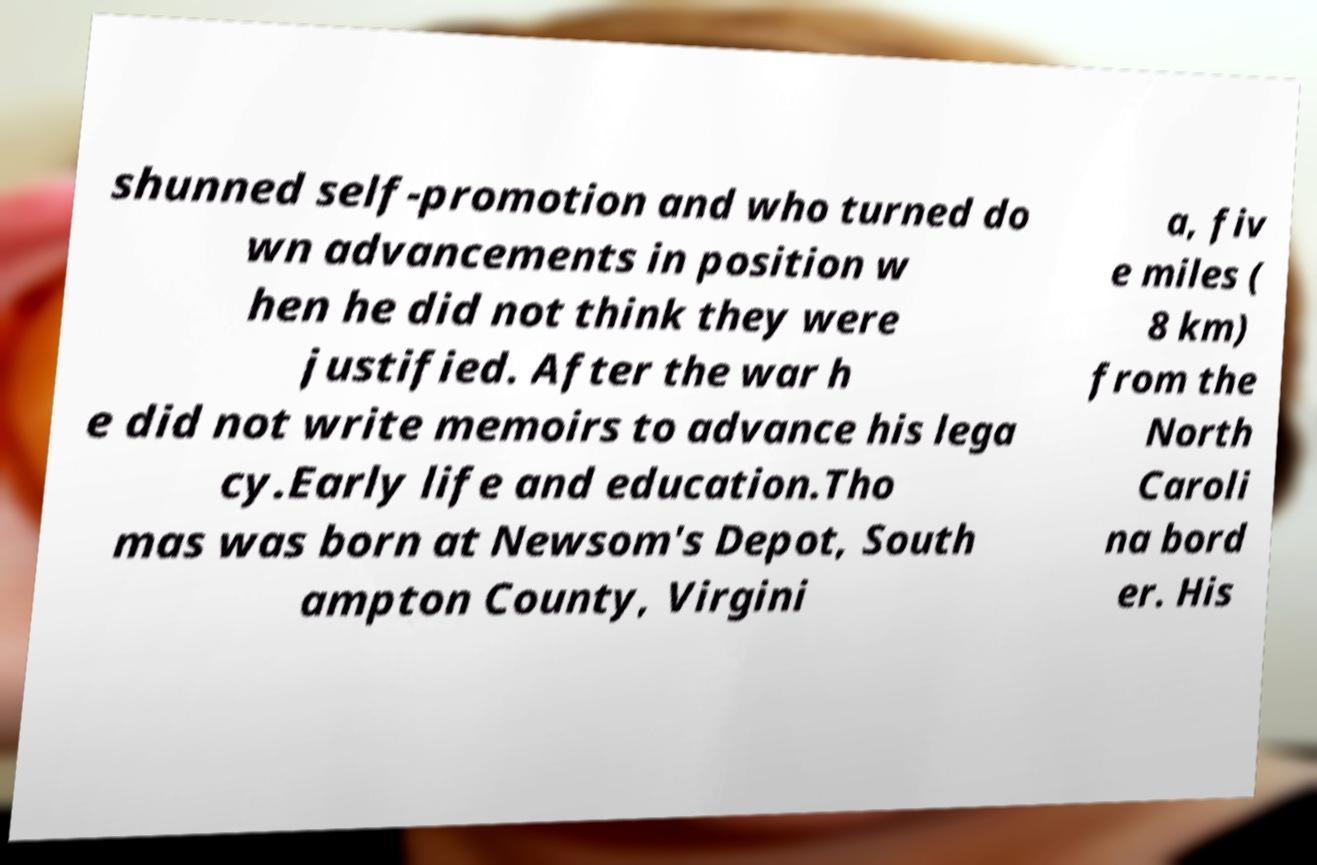For documentation purposes, I need the text within this image transcribed. Could you provide that? shunned self-promotion and who turned do wn advancements in position w hen he did not think they were justified. After the war h e did not write memoirs to advance his lega cy.Early life and education.Tho mas was born at Newsom's Depot, South ampton County, Virgini a, fiv e miles ( 8 km) from the North Caroli na bord er. His 